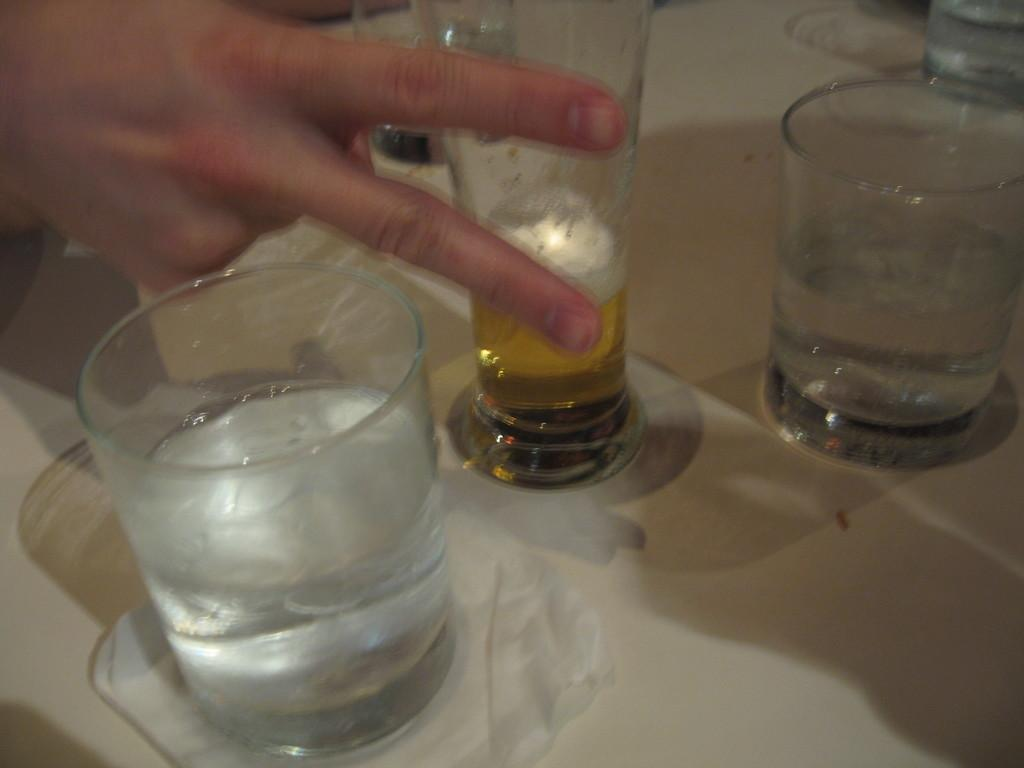What objects are on the table in the image? There are glasses on a table in the image. Can you describe anything else visible in the image? A person's hand is visible in the image. What type of wren is sitting on the glasses in the image? There is no wren present in the image; only glasses and a person's hand are visible. 